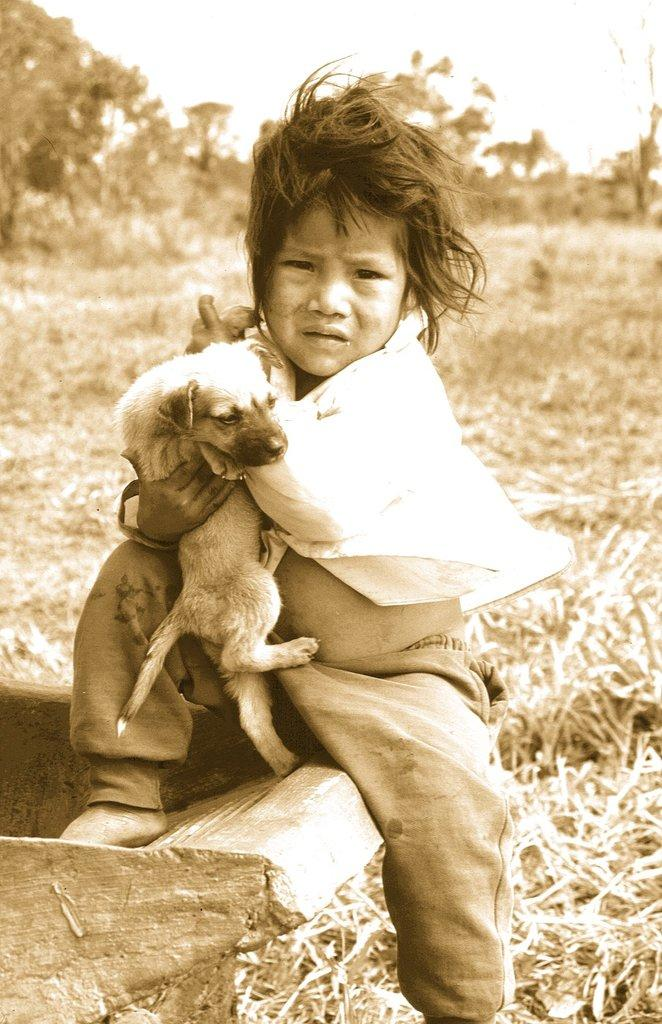What is the child doing in the image? The child is sitting in the image and holding a dog in their hands. What can be seen in the background of the image? There are trees visible in the background of the image. What type of surface is the child sitting on? The grass in the image suggests that the child is sitting on a grassy surface. What type of haircut does the dog have in the image? There is no mention of the dog's haircut in the image, as the focus is on the child holding the dog. 